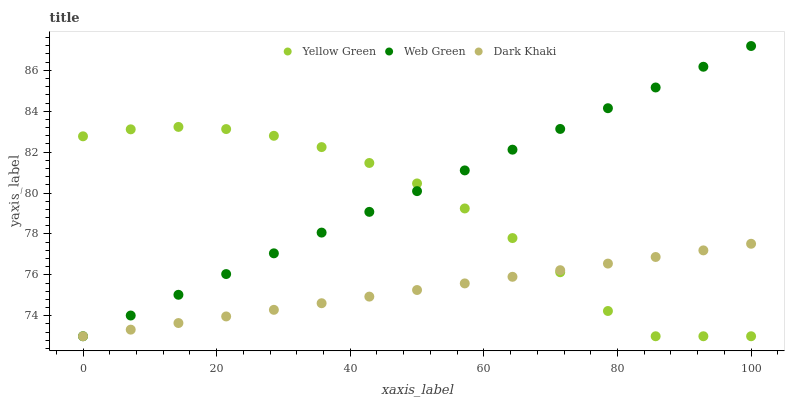Does Dark Khaki have the minimum area under the curve?
Answer yes or no. Yes. Does Web Green have the maximum area under the curve?
Answer yes or no. Yes. Does Yellow Green have the minimum area under the curve?
Answer yes or no. No. Does Yellow Green have the maximum area under the curve?
Answer yes or no. No. Is Dark Khaki the smoothest?
Answer yes or no. Yes. Is Yellow Green the roughest?
Answer yes or no. Yes. Is Web Green the smoothest?
Answer yes or no. No. Is Web Green the roughest?
Answer yes or no. No. Does Dark Khaki have the lowest value?
Answer yes or no. Yes. Does Web Green have the highest value?
Answer yes or no. Yes. Does Yellow Green have the highest value?
Answer yes or no. No. Does Web Green intersect Yellow Green?
Answer yes or no. Yes. Is Web Green less than Yellow Green?
Answer yes or no. No. Is Web Green greater than Yellow Green?
Answer yes or no. No. 